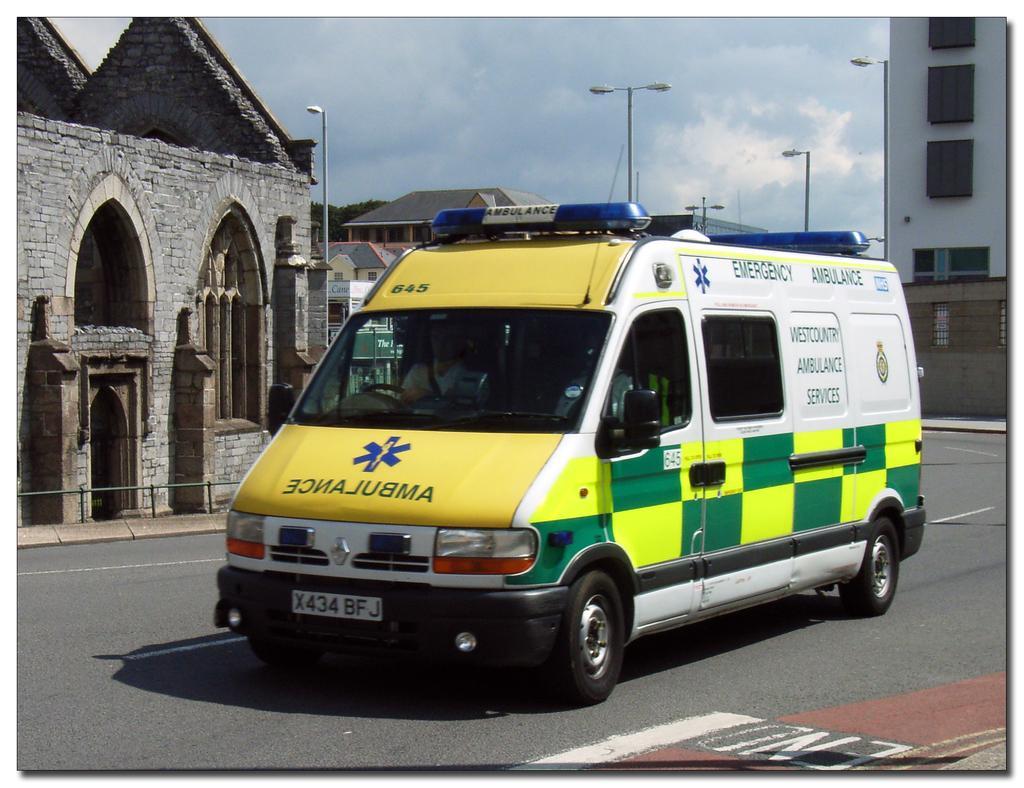Could you give a brief overview of what you see in this image? In the picture we can see a road on it, we can see an ambulance van and behind it, we can see some house building and near to it, we can see a path with street lights and to the opposite side also we can see some buildings and near to it also we can see some street lights to the poles and in the background we can see a sky. 